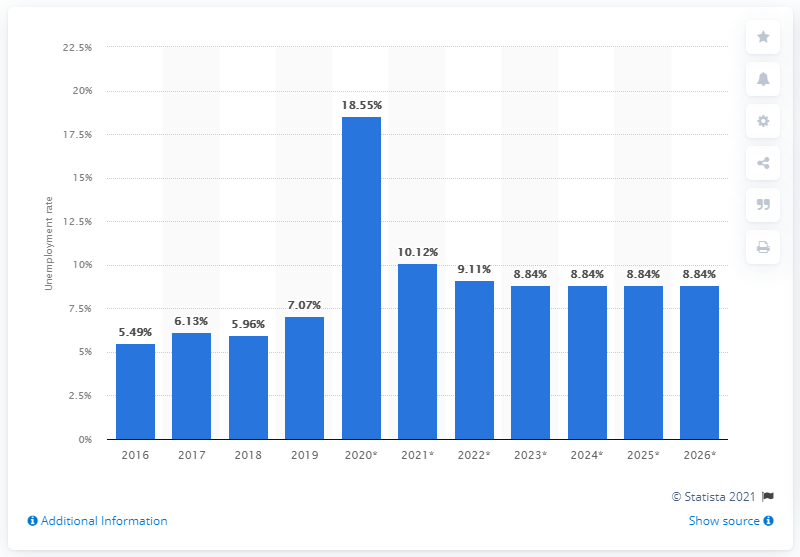Highlight a few significant elements in this photo. In 2019, the unemployment rate in Panama was 7.07%. In 2016, the unemployment rate in Panama was. 